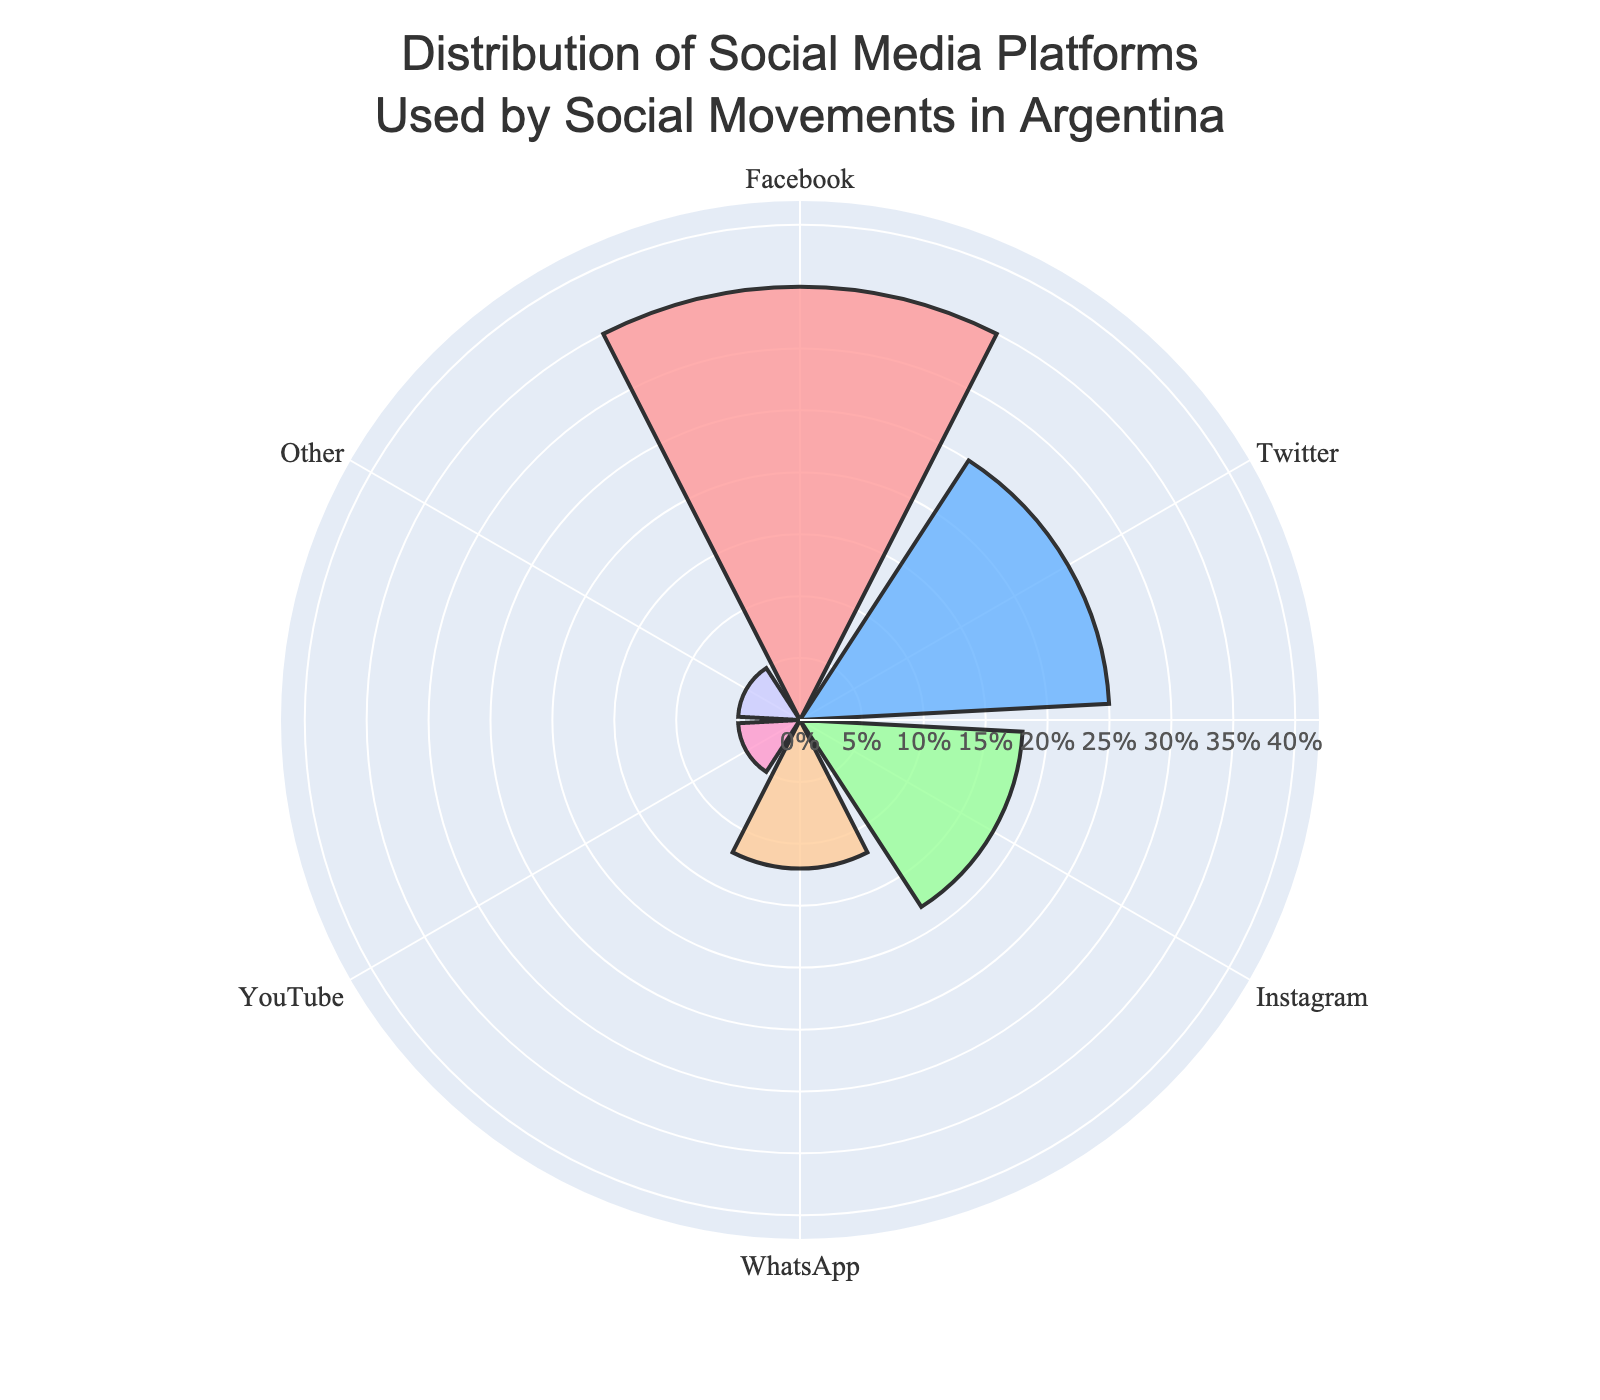What is the title of the chart? The title is usually prominently displayed at the top of a chart and provides an overview of what the chart represents. In this case, the title reads "Distribution of Social Media Platforms Used by Social Movements in Argentina."
Answer: Distribution of Social Media Platforms Used by Social Movements in Argentina Which social media platform has the highest usage percentage among social movements in Argentina? By examining the lengths of the bars in the polar area chart, we can see that the longest bar corresponds to Facebook, which indicates the highest usage percentage.
Answer: Facebook What is the combined percentage of usage for Instagram, WhatsApp, and YouTube? To find the combined percentage, add the individual percentages of the three platforms: Instagram (18%), WhatsApp (12%), and YouTube (5%). The sum is 18% + 12% + 5% = 35%.
Answer: 35% How much greater is the usage percentage of Twitter compared to YouTube among social movements in Argentina? To determine how much greater Twitter's usage percentage is than YouTube's, subtract YouTube's percentage (5%) from Twitter's percentage (25%). The calculation is 25% - 5% = 20%.
Answer: 20% Which platform has the smallest usage percentage, and what is its percentage? The smallest segments in the polar area chart correspond to the shortest bars. Both YouTube and 'Other' occupy the smallest segments with an equal percentage of usage. Hence, YouTube and 'Other' are the platforms with the smallest usage percentage, which is 5%.
Answer: YouTube and Other, 5% What's the total percentage of social media platforms other than Facebook used by social movements in Argentina? To find the total percentage of all platforms other than Facebook, add the percentages of Twitter (25%), Instagram (18%), WhatsApp (12%), YouTube (5%), and 'Other' (5%). The calculation is 25% + 18% + 12% + 5% + 5% = 65%.
Answer: 65% Of the platforms listed, which one has a usage percentage that is closest to the median value, and what is this value? The median value of a dataset is the middle number when sorted in ascending order. The sorted percentages are 5%, 5%, 12%, 18%, 25%, and 35%. The median lies between the third and fourth values: (12 + 18) / 2 = 15%. WhatsApp, with 12%, is closest to this median value.
Answer: WhatsApp, 12% Which platform's representation is closest to 20%? By visually inspecting the lengths of the bars, Instagram has the percentage that is closest to 20%, with a value of 18%.
Answer: Instagram What color is used to represent the WhatsApp platform in the chart? The color for each platform can be identified by associating the platform labels with the corresponding colored segments. WhatsApp is represented using an orange-like color (#FFCC99).
Answer: Orange How do the usage percentages of Facebook and Twitter combined compare to the total of all other platforms? To compare, first find Facebook plus Twitter: 35% + 25% = 60%. Next, find the total of all other platforms: Instagram (18%) + WhatsApp (12%) + YouTube (5%) + 'Other' (5%) = 40%. Facebook and Twitter combined (60%) are greater than the total of all other platforms (40%).
Answer: 60% vs. 40% 